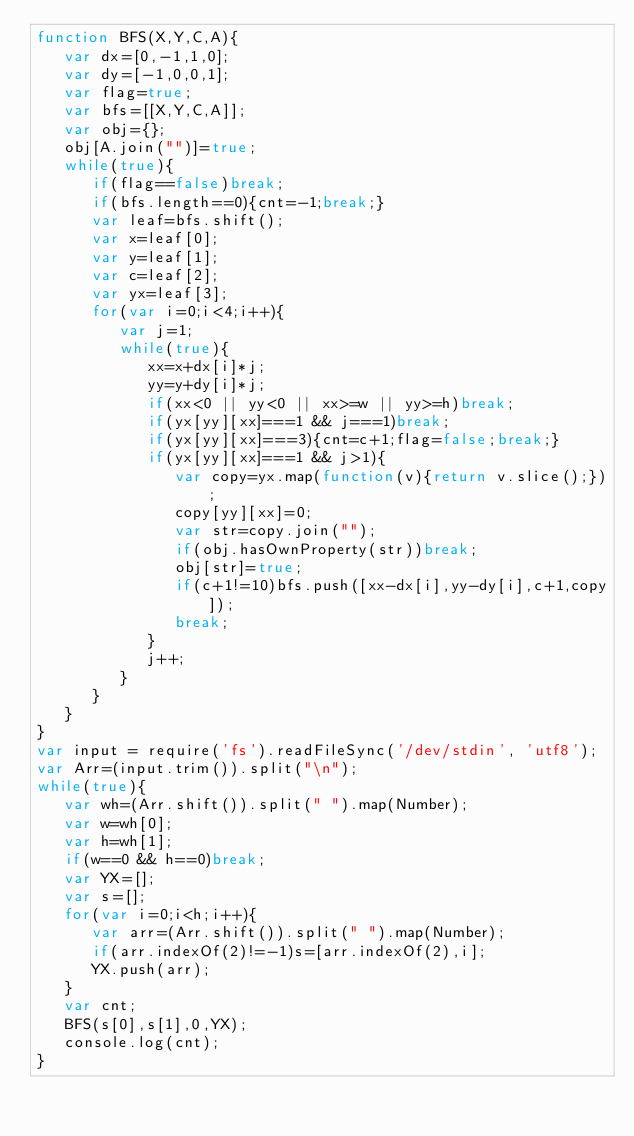<code> <loc_0><loc_0><loc_500><loc_500><_JavaScript_>function BFS(X,Y,C,A){
   var dx=[0,-1,1,0];
   var dy=[-1,0,0,1];
   var flag=true;
   var bfs=[[X,Y,C,A]];
   var obj={};
   obj[A.join("")]=true;
   while(true){
      if(flag==false)break;
      if(bfs.length==0){cnt=-1;break;}
      var leaf=bfs.shift();
      var x=leaf[0];
      var y=leaf[1];
      var c=leaf[2];
      var yx=leaf[3];
      for(var i=0;i<4;i++){
         var j=1;
         while(true){
            xx=x+dx[i]*j;
            yy=y+dy[i]*j;
            if(xx<0 || yy<0 || xx>=w || yy>=h)break;
            if(yx[yy][xx]===1 && j===1)break;
            if(yx[yy][xx]===3){cnt=c+1;flag=false;break;}
            if(yx[yy][xx]===1 && j>1){
               var copy=yx.map(function(v){return v.slice();});
               copy[yy][xx]=0;
               var str=copy.join("");
               if(obj.hasOwnProperty(str))break;
               obj[str]=true;
               if(c+1!=10)bfs.push([xx-dx[i],yy-dy[i],c+1,copy]);
               break;
            }
            j++;
         }
      }
   }
}
var input = require('fs').readFileSync('/dev/stdin', 'utf8');
var Arr=(input.trim()).split("\n");
while(true){
   var wh=(Arr.shift()).split(" ").map(Number);
   var w=wh[0];
   var h=wh[1];
   if(w==0 && h==0)break;
   var YX=[];
   var s=[];
   for(var i=0;i<h;i++){
      var arr=(Arr.shift()).split(" ").map(Number);
      if(arr.indexOf(2)!=-1)s=[arr.indexOf(2),i];
      YX.push(arr);
   }
   var cnt;
   BFS(s[0],s[1],0,YX);
   console.log(cnt);
}</code> 